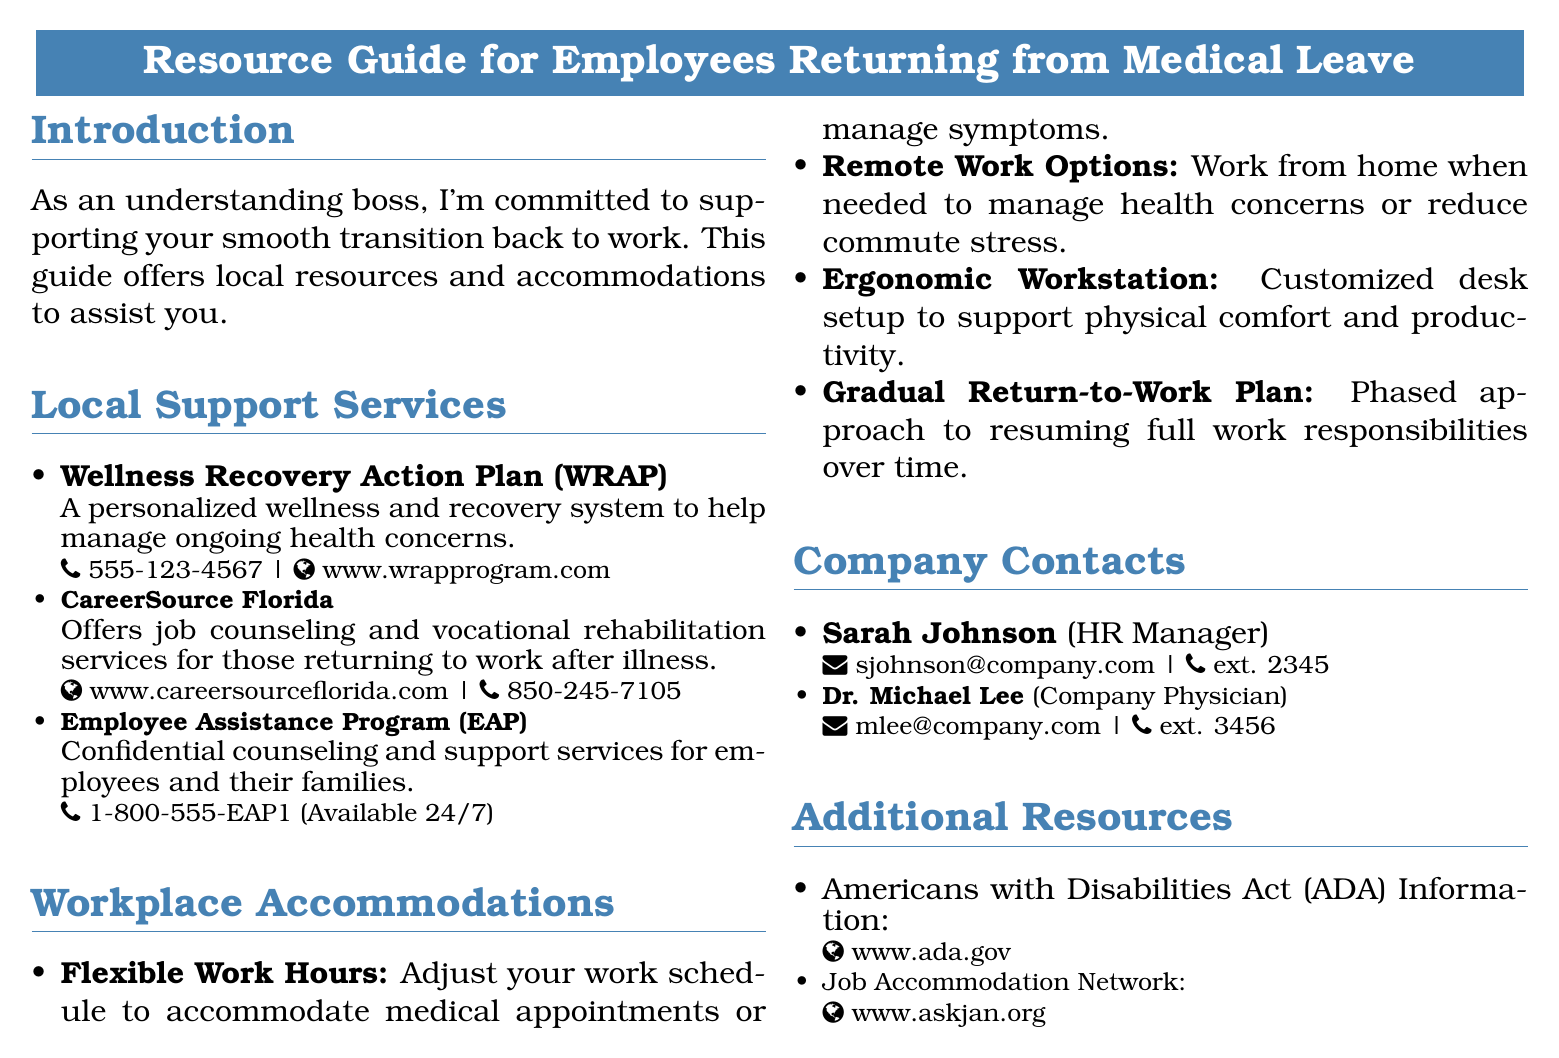What is the phone number for the Wellness Recovery Action Plan? The phone number is listed in the document under the Wellness Recovery Action Plan section.
Answer: 555-123-4567 Who is the HR Manager? The HR Manager’s name is mentioned in the Company Contacts section of the document.
Answer: Sarah Johnson What type of support does the Employee Assistance Program provide? The document states that the EAP offers counseling and support services for employees and their families.
Answer: Confidential counseling What is one type of workplace accommodation listed? The document lists several accommodations provided for employees returning to work.
Answer: Flexible Work Hours What website can you visit for Americans with Disabilities Act information? The document provides a link in the Additional Resources section for ADA information.
Answer: www.ada.gov What kind of services does CareerSource Florida offer? The document mentions that CareerSource Florida offers job counseling and vocational rehabilitation services.
Answer: Job counseling How can employees contact the Company Physician? The document provides contact information for the Company Physician in the Company Contacts section.
Answer: mlee@company.com What is a Gradual Return-to-Work Plan? The document defines this accommodation as a phased approach to resuming full work responsibilities over time.
Answer: Phased approach What local support service helps manage ongoing health concerns? The document lists a specific service that focuses on this type of support.
Answer: Wellness Recovery Action Plan 